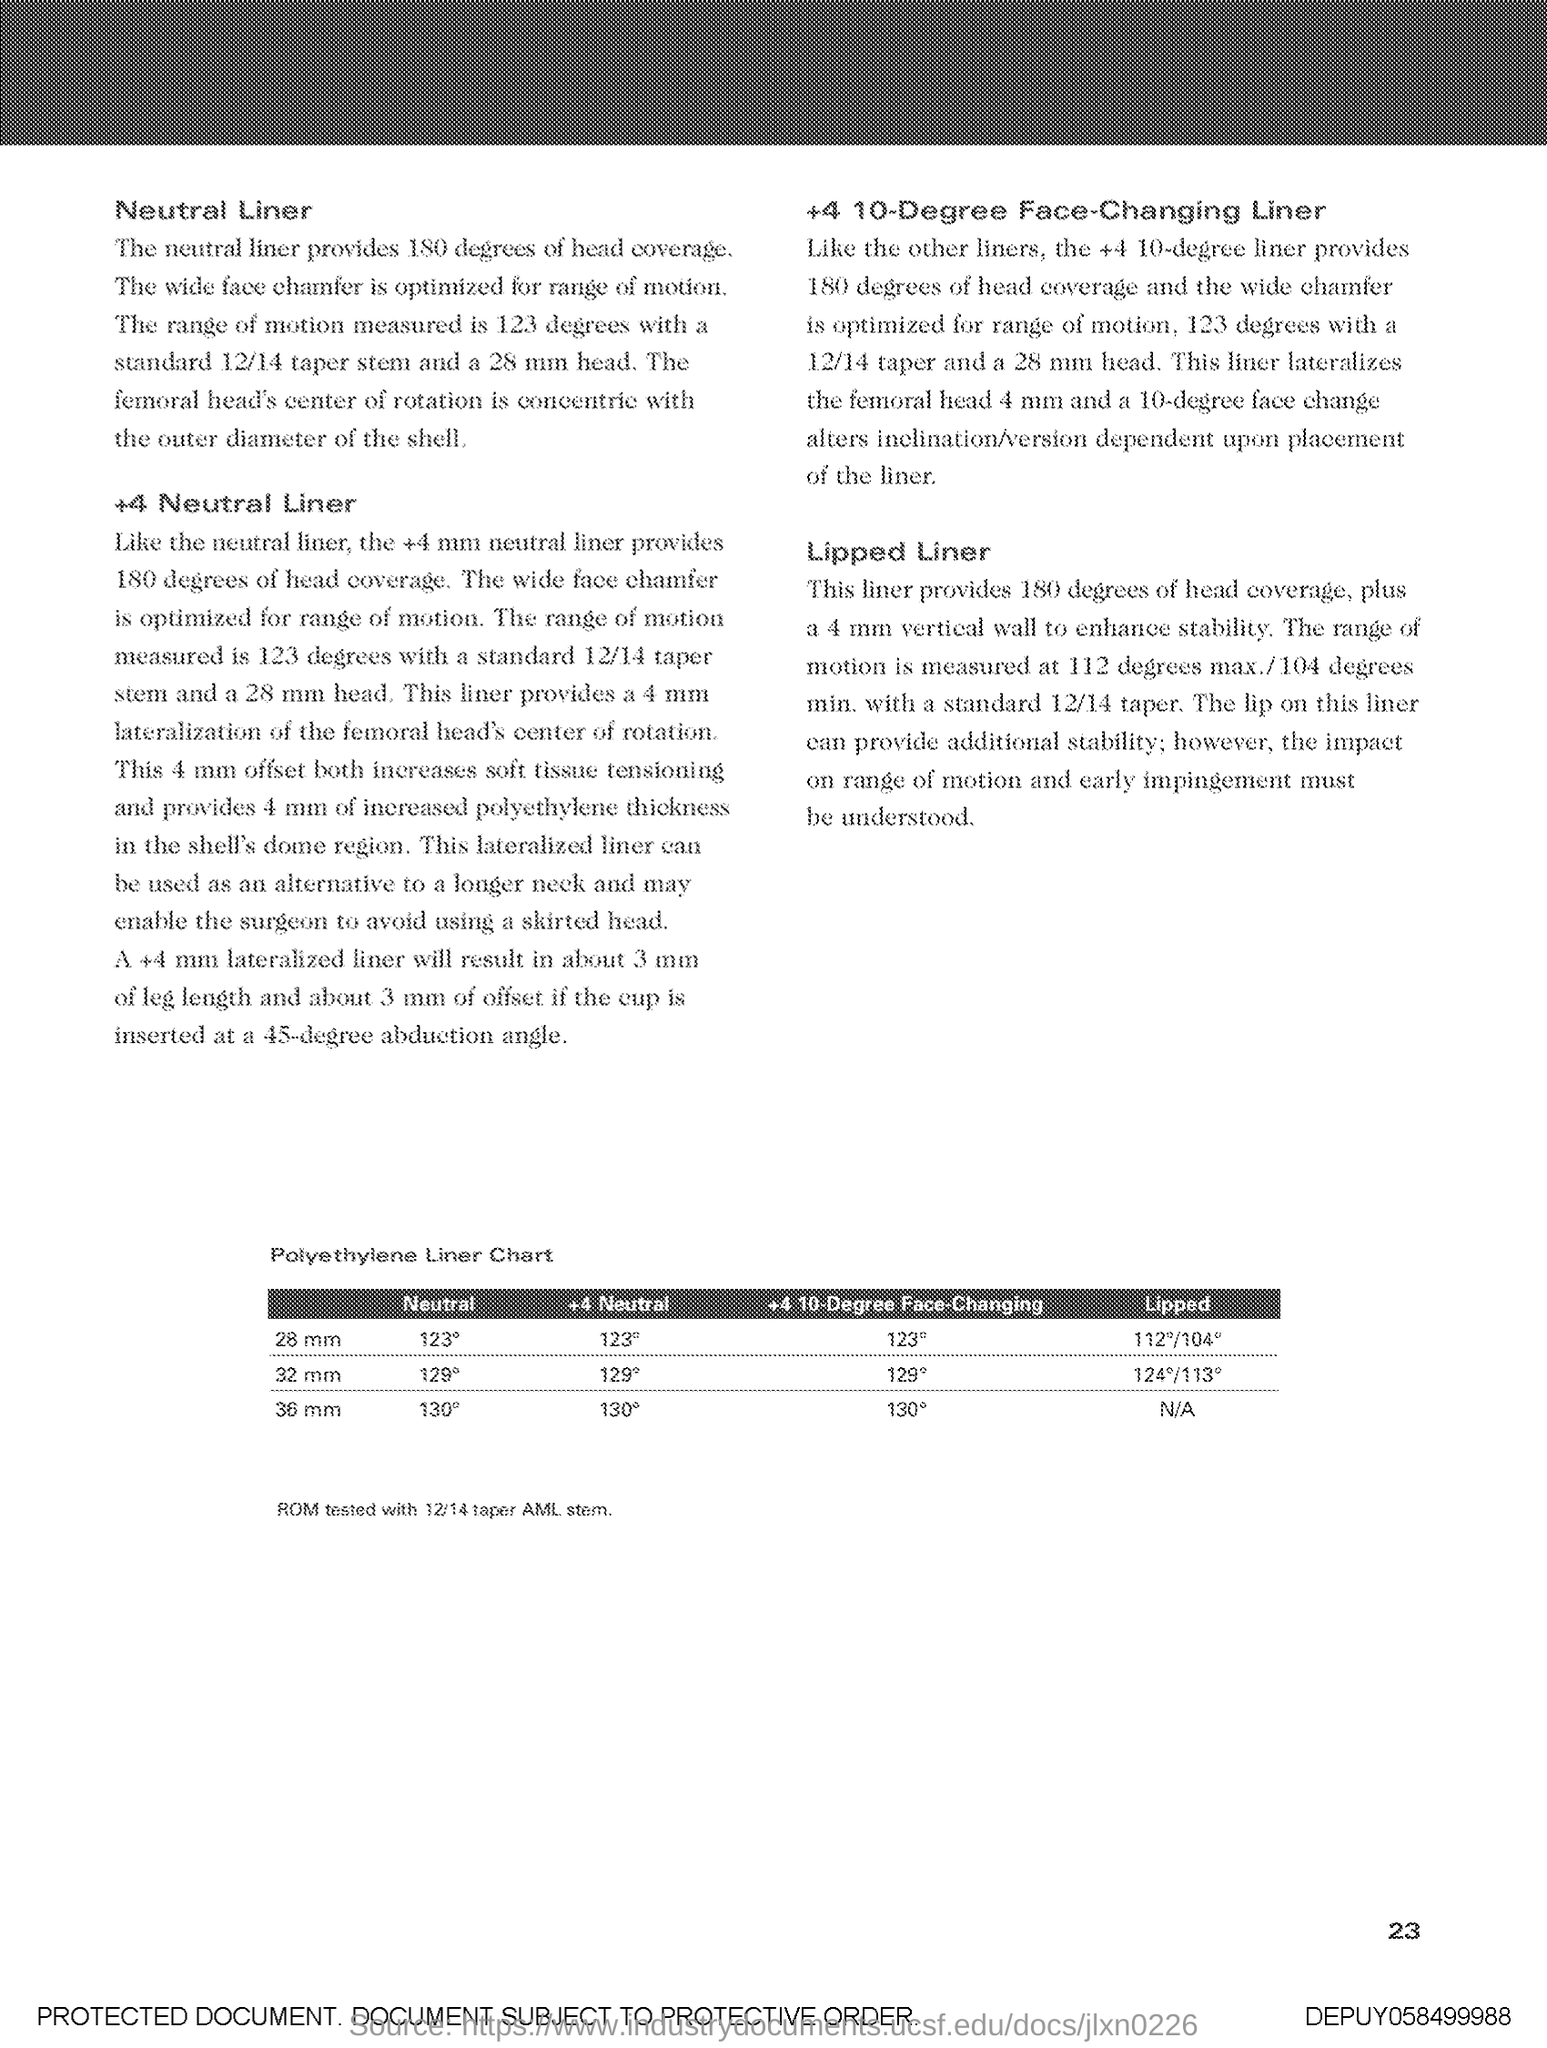What is the title of the table?
Provide a succinct answer. Polyethylene Liner Chart. 